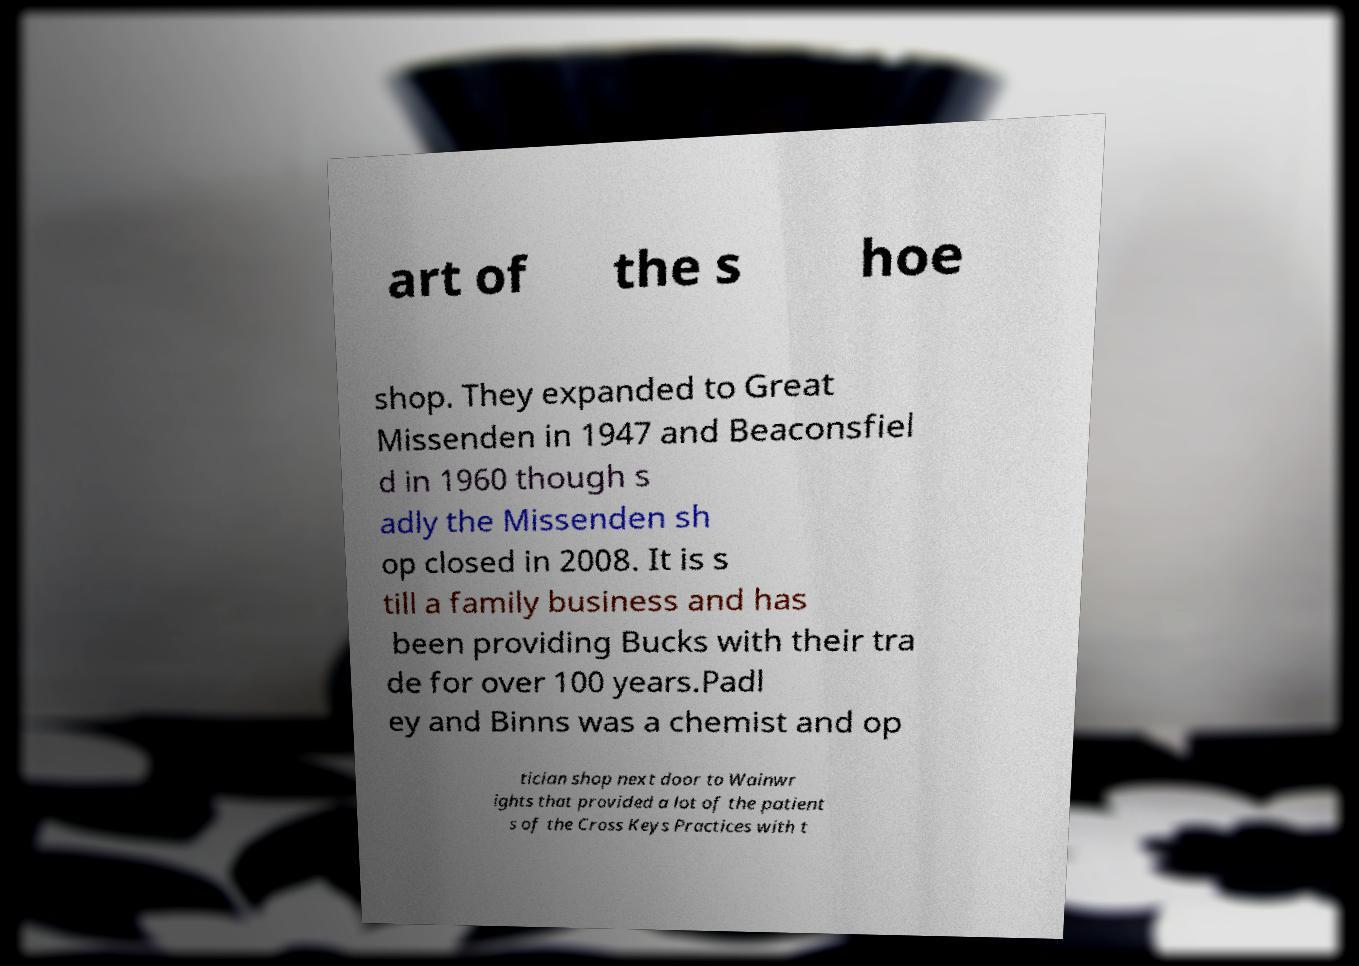Could you extract and type out the text from this image? art of the s hoe shop. They expanded to Great Missenden in 1947 and Beaconsfiel d in 1960 though s adly the Missenden sh op closed in 2008. It is s till a family business and has been providing Bucks with their tra de for over 100 years.Padl ey and Binns was a chemist and op tician shop next door to Wainwr ights that provided a lot of the patient s of the Cross Keys Practices with t 